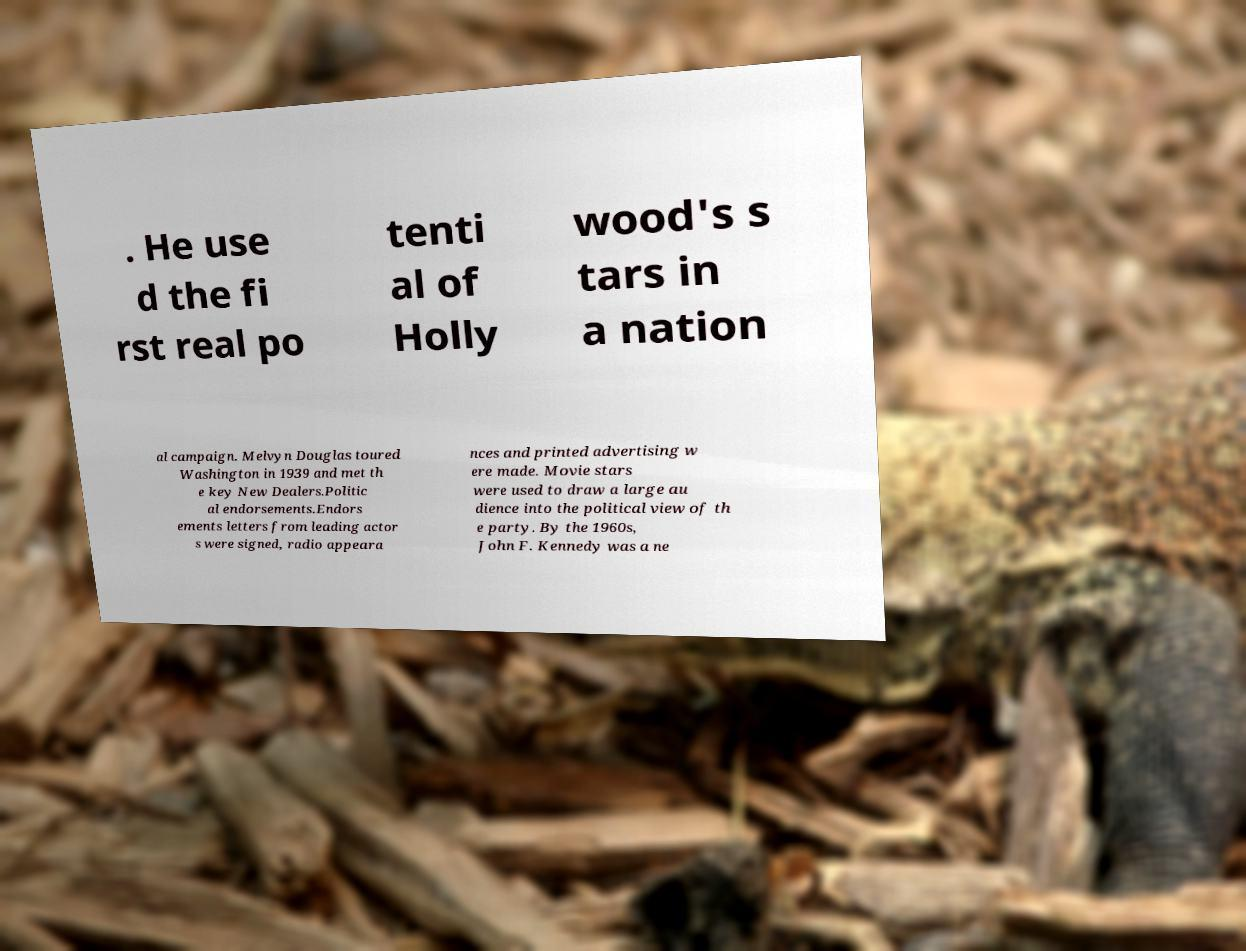Could you assist in decoding the text presented in this image and type it out clearly? . He use d the fi rst real po tenti al of Holly wood's s tars in a nation al campaign. Melvyn Douglas toured Washington in 1939 and met th e key New Dealers.Politic al endorsements.Endors ements letters from leading actor s were signed, radio appeara nces and printed advertising w ere made. Movie stars were used to draw a large au dience into the political view of th e party. By the 1960s, John F. Kennedy was a ne 